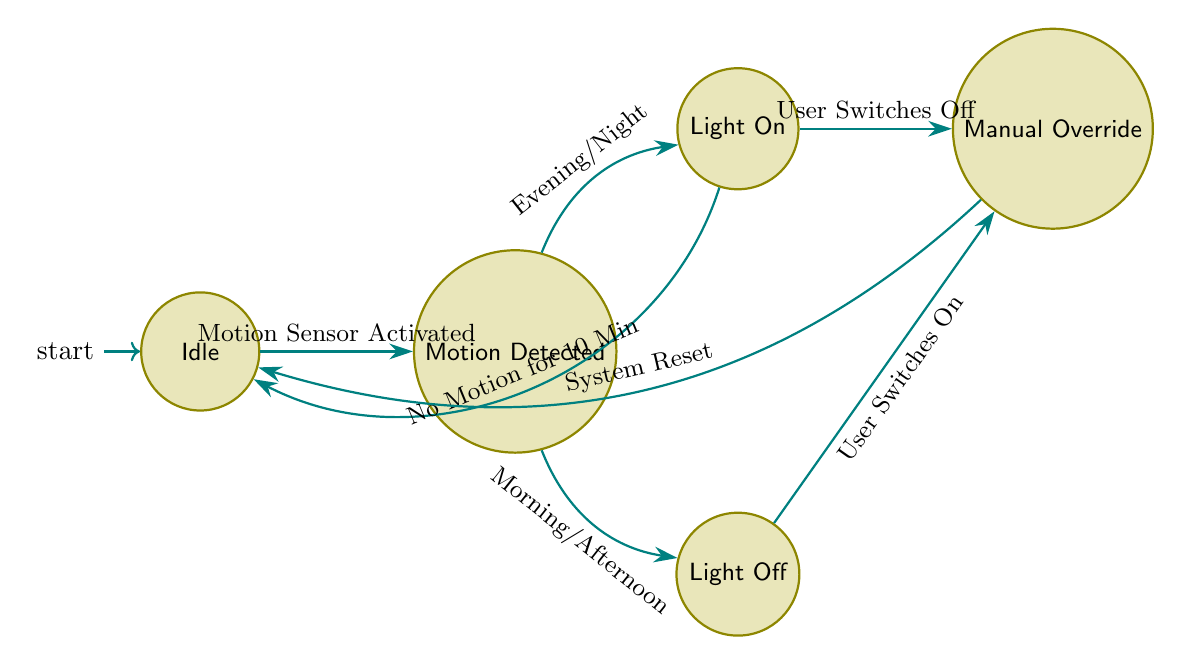What is the initial state of the system? The diagram indicates that the system starts in the "Idle" state, labeled as the initial state.
Answer: Idle How many states are there in the system? By counting the different states labeled in the diagram, we see there are five states: Idle, Motion Detected, Light On, Light Off, and Manual Override.
Answer: 5 What triggers the transition from "Idle" to "Motion Detected"? The transition from "Idle" to "Motion Detected" occurs when the "Motion Sensor Activated" signal is received, as depicted in the connecting edge.
Answer: Motion Sensor Activated What happens when "Light On" has no motion detected for 10 minutes? In the "Light On" state, if there is no motion detected for 10 minutes, the system transitions back to the "Idle" state, as shown by the arrow pointing back to "Idle."
Answer: Idle What are the two possible transitions from "Motion Detected"? From the "Motion Detected" state, the system can transition to either "Light On" triggered by "Time of Day: Evening or Night" or to "Light Off" triggered by "Time of Day: Morning or Afternoon."
Answer: Light On and Light Off What state does the system go to when the user switches off the light while it is currently "Light On"? When the user switches off the light while in the "Light On" state, the system transitions to the "Manual Override" state, as indicated by the associated edge.
Answer: Manual Override How many transitions lead to the "Manual Override" state? Looking at the diagram, there are two transitions that lead to the "Manual Override" state: one from "Light On" when the user switches off the light and one from "Light Off" when the user switches on the light.
Answer: 2 When the system is in "Light Off," what must occur to return it to the "Idle" state? For the system to return to the "Idle" state from "Light Off," the user must perform a "System Reset," as indicated by the transition leading to "Idle."
Answer: System Reset What triggers the transition from "Light On" back to "Idle"? The transition from "Light On" back to "Idle" occurs if there is "No Motion Detected for 10 Minutes," as shown in the diagram.
Answer: No Motion Detected for 10 Minutes 